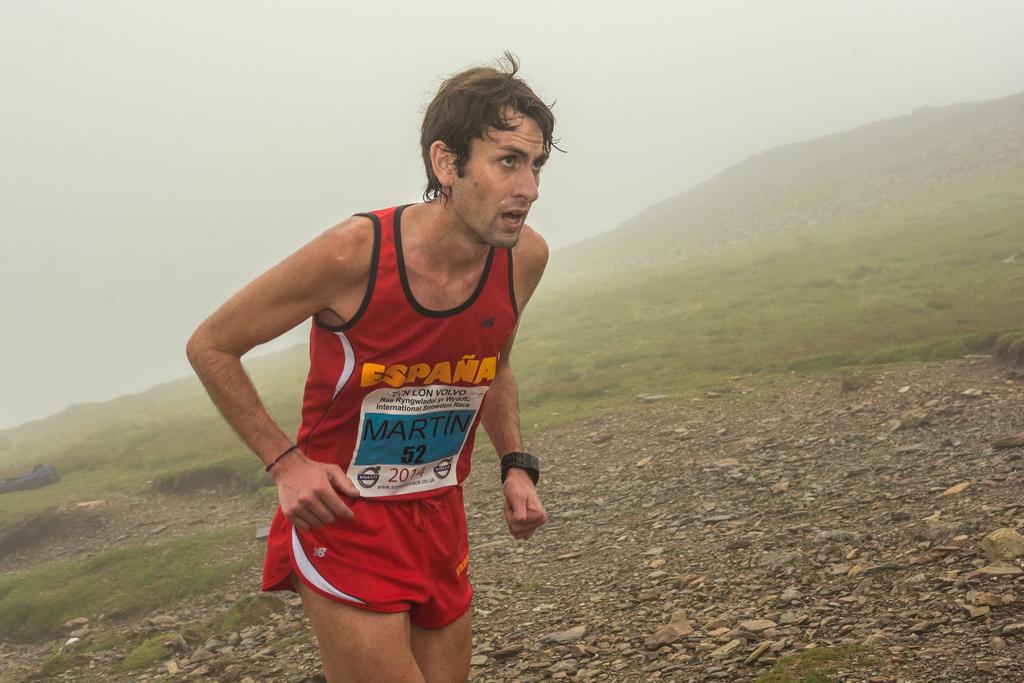<image>
Describe the image concisely. runner with red jersey that has espana on it and tag that has martin 52 and year 2014 